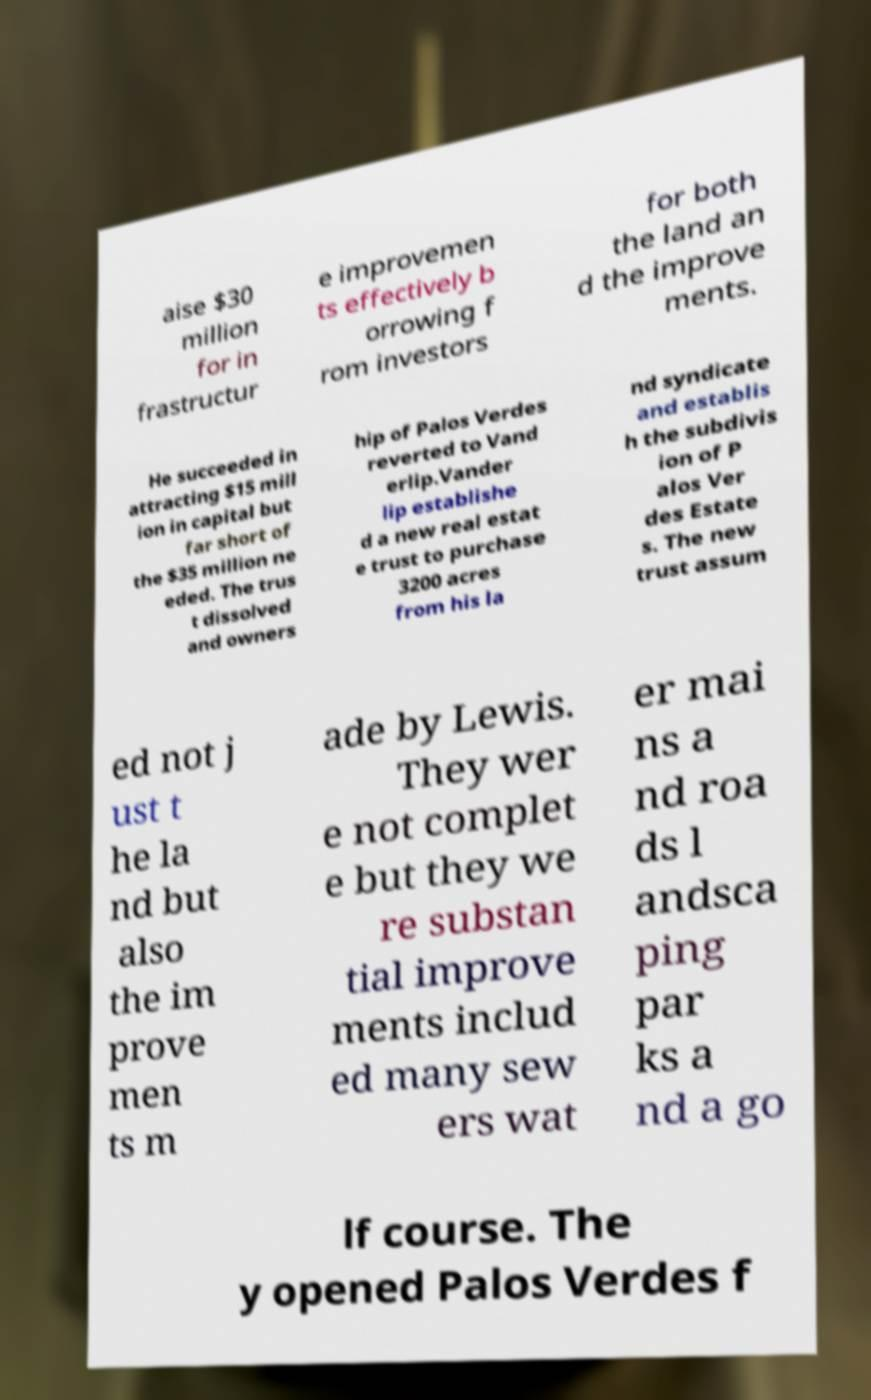Can you accurately transcribe the text from the provided image for me? aise $30 million for in frastructur e improvemen ts effectively b orrowing f rom investors for both the land an d the improve ments. He succeeded in attracting $15 mill ion in capital but far short of the $35 million ne eded. The trus t dissolved and owners hip of Palos Verdes reverted to Vand erlip.Vander lip establishe d a new real estat e trust to purchase 3200 acres from his la nd syndicate and establis h the subdivis ion of P alos Ver des Estate s. The new trust assum ed not j ust t he la nd but also the im prove men ts m ade by Lewis. They wer e not complet e but they we re substan tial improve ments includ ed many sew ers wat er mai ns a nd roa ds l andsca ping par ks a nd a go lf course. The y opened Palos Verdes f 